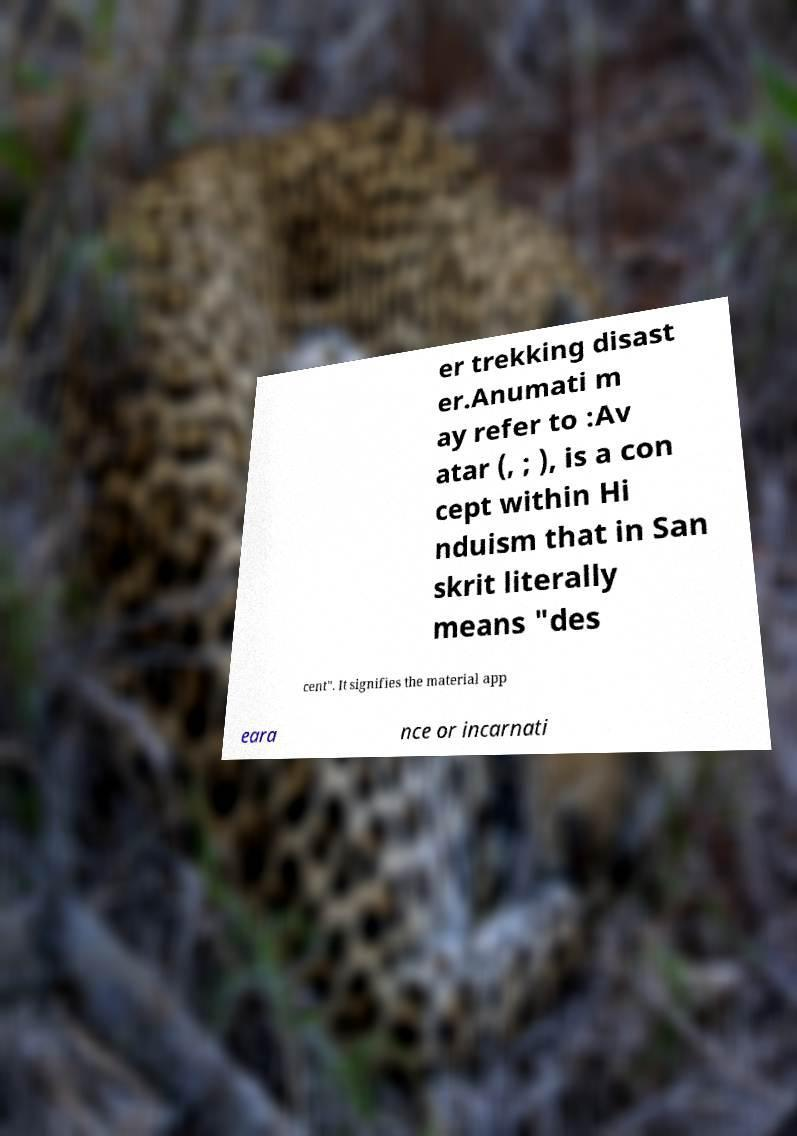For documentation purposes, I need the text within this image transcribed. Could you provide that? er trekking disast er.Anumati m ay refer to :Av atar (, ; ), is a con cept within Hi nduism that in San skrit literally means "des cent". It signifies the material app eara nce or incarnati 